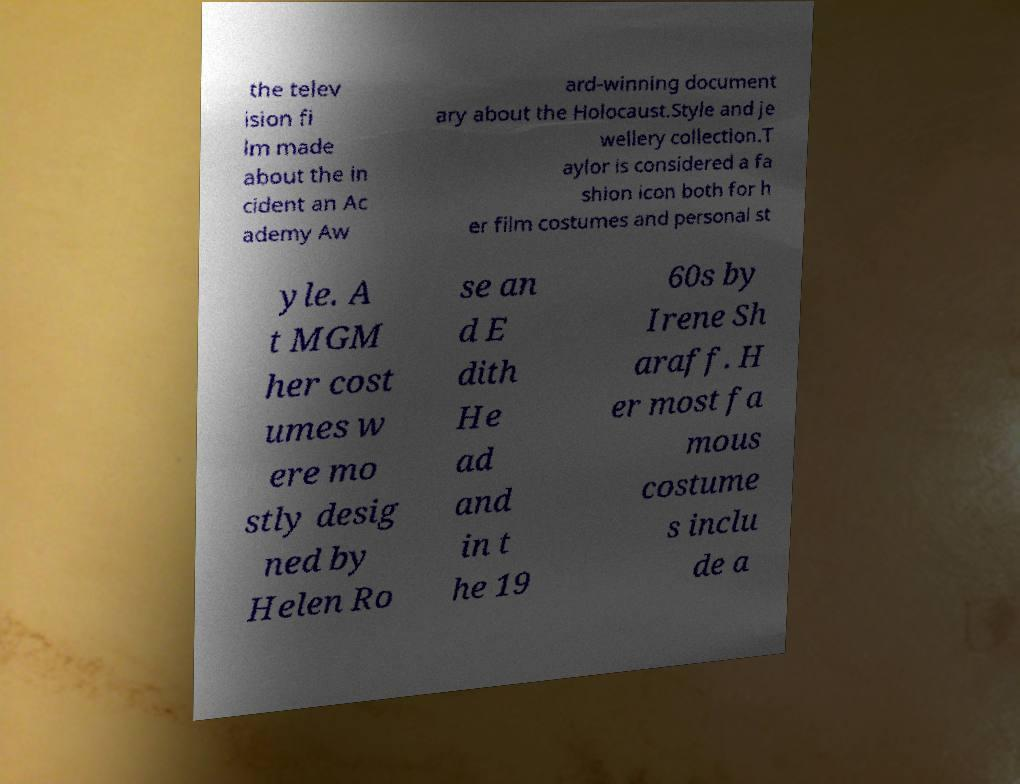What messages or text are displayed in this image? I need them in a readable, typed format. the telev ision fi lm made about the in cident an Ac ademy Aw ard-winning document ary about the Holocaust.Style and je wellery collection.T aylor is considered a fa shion icon both for h er film costumes and personal st yle. A t MGM her cost umes w ere mo stly desig ned by Helen Ro se an d E dith He ad and in t he 19 60s by Irene Sh araff. H er most fa mous costume s inclu de a 